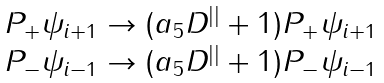Convert formula to latex. <formula><loc_0><loc_0><loc_500><loc_500>\begin{array} { l } P _ { + } \psi _ { i + 1 } \rightarrow ( a _ { 5 } D ^ { | | } + 1 ) P _ { + } \psi _ { i + 1 } \\ P _ { - } \psi _ { i - 1 } \rightarrow ( a _ { 5 } D ^ { | | } + 1 ) P _ { - } \psi _ { i - 1 } \end{array}</formula> 